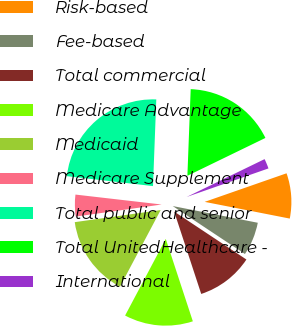Convert chart to OTSL. <chart><loc_0><loc_0><loc_500><loc_500><pie_chart><fcel>Risk-based<fcel>Fee-based<fcel>Total commercial<fcel>Medicare Advantage<fcel>Medicaid<fcel>Medicare Supplement<fcel>Total public and senior<fcel>Total UnitedHealthcare -<fcel>International<nl><fcel>8.43%<fcel>6.24%<fcel>10.62%<fcel>12.82%<fcel>15.01%<fcel>4.05%<fcel>23.78%<fcel>17.2%<fcel>1.85%<nl></chart> 